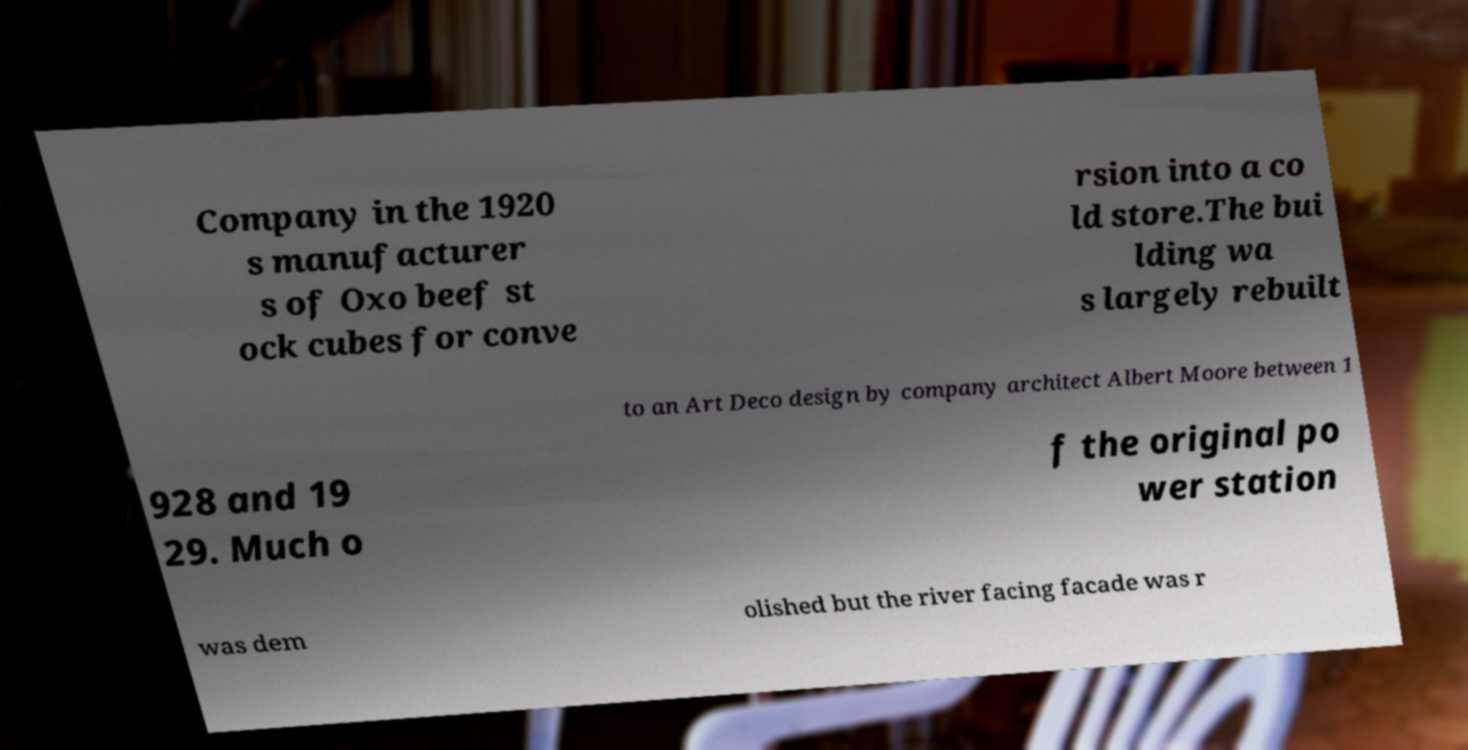For documentation purposes, I need the text within this image transcribed. Could you provide that? Company in the 1920 s manufacturer s of Oxo beef st ock cubes for conve rsion into a co ld store.The bui lding wa s largely rebuilt to an Art Deco design by company architect Albert Moore between 1 928 and 19 29. Much o f the original po wer station was dem olished but the river facing facade was r 